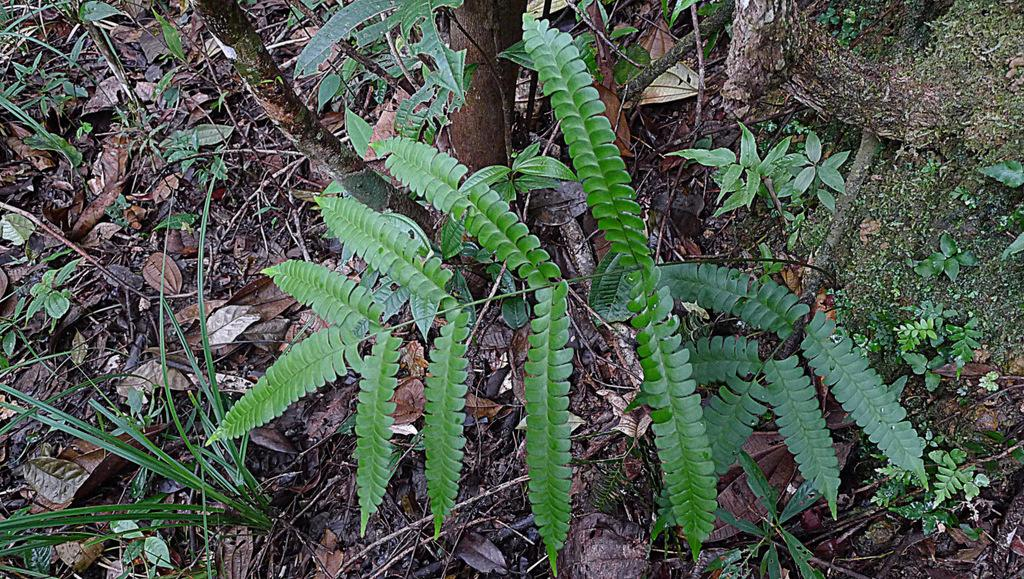What type of vegetation can be seen in the image? There are plants and grass visible in the image. What is a characteristic of some of the plants in the image? Dried leaves are present in the image. What part of the trees can be seen in the image? Tree barks are visible in the image. Where is the hydrant located in the image? There is no hydrant present in the image. What type of net is used for catching the plants in the image? There is no net present in the image, and plants are not being caught. 